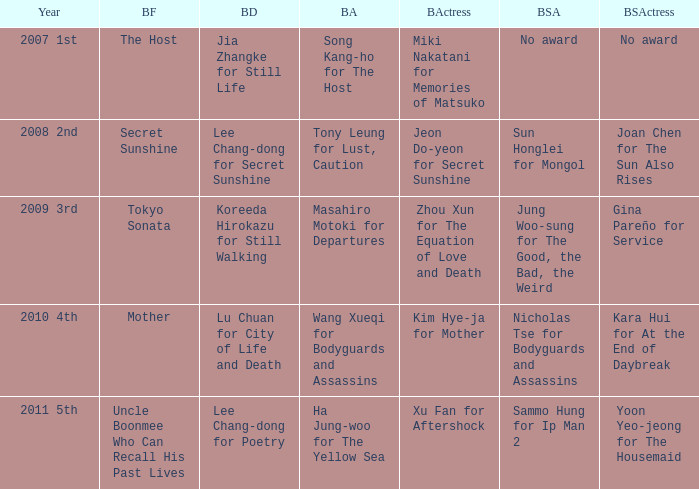Name the best actor for uncle boonmee who can recall his past lives Ha Jung-woo for The Yellow Sea. 